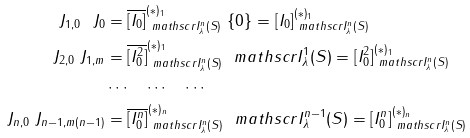<formula> <loc_0><loc_0><loc_500><loc_500>J _ { 1 , 0 } \ J _ { 0 } & = \overline { [ I _ { 0 } ] } ^ { ( \ast ) _ { 1 } } _ { \ m a t h s c r { I } _ { \lambda } ^ { n } ( S ) } \ \{ 0 \} = [ I _ { 0 } ] ^ { ( \ast ) _ { 1 } } _ { \ m a t h s c r { I } _ { \lambda } ^ { n } ( S ) } \\ J _ { 2 , 0 } \ J _ { 1 , m } & = \overline { [ I _ { 0 } ^ { 2 } ] } ^ { ( \ast ) _ { 1 } } _ { \ m a t h s c r { I } _ { \lambda } ^ { n } ( S ) } \ \ m a t h s c r { I } _ { \lambda } ^ { 1 } ( S ) = [ I _ { 0 } ^ { 2 } ] ^ { ( \ast ) _ { 1 } } _ { \ m a t h s c r { I } _ { \lambda } ^ { n } ( S ) } \\ & \cdots \quad \cdots \quad \cdots \\ J _ { n , 0 } \ J _ { n - 1 , m ( n - 1 ) } & = \overline { [ I _ { 0 } ^ { n } ] } ^ { ( \ast ) _ { n } } _ { \ m a t h s c r { I } _ { \lambda } ^ { n } ( S ) } \ \ m a t h s c r { I } _ { \lambda } ^ { n - 1 } ( S ) = [ I _ { 0 } ^ { n } ] ^ { ( \ast ) _ { n } } _ { \ m a t h s c r { I } _ { \lambda } ^ { n } ( S ) }</formula> 